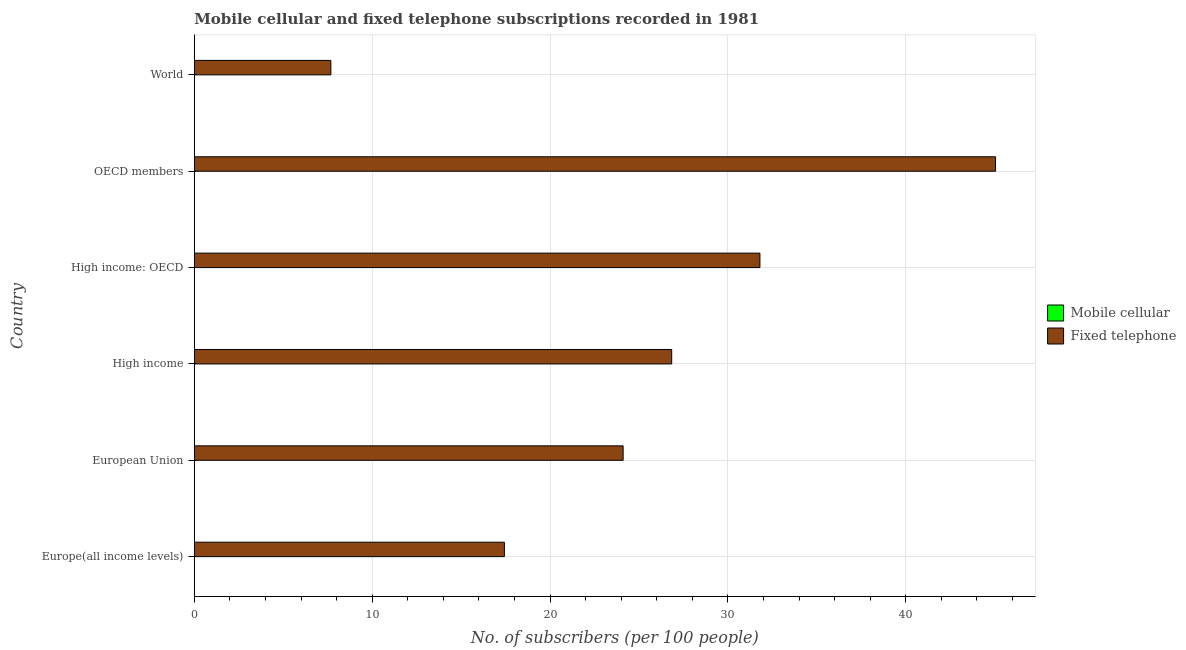How many groups of bars are there?
Your answer should be compact. 6. Are the number of bars per tick equal to the number of legend labels?
Make the answer very short. Yes. How many bars are there on the 4th tick from the bottom?
Ensure brevity in your answer.  2. What is the label of the 1st group of bars from the top?
Provide a short and direct response. World. In how many cases, is the number of bars for a given country not equal to the number of legend labels?
Ensure brevity in your answer.  0. What is the number of fixed telephone subscribers in High income?
Keep it short and to the point. 26.84. Across all countries, what is the maximum number of mobile cellular subscribers?
Ensure brevity in your answer.  0.01. Across all countries, what is the minimum number of mobile cellular subscribers?
Give a very brief answer. 0. In which country was the number of fixed telephone subscribers maximum?
Make the answer very short. OECD members. In which country was the number of mobile cellular subscribers minimum?
Offer a very short reply. World. What is the total number of fixed telephone subscribers in the graph?
Offer a terse response. 152.9. What is the difference between the number of fixed telephone subscribers in Europe(all income levels) and that in OECD members?
Your response must be concise. -27.61. What is the difference between the number of fixed telephone subscribers in World and the number of mobile cellular subscribers in High income: OECD?
Keep it short and to the point. 7.67. What is the average number of mobile cellular subscribers per country?
Make the answer very short. 0.01. What is the difference between the number of mobile cellular subscribers and number of fixed telephone subscribers in High income: OECD?
Your answer should be very brief. -31.79. In how many countries, is the number of fixed telephone subscribers greater than 42 ?
Offer a terse response. 1. What is the ratio of the number of mobile cellular subscribers in European Union to that in High income: OECD?
Keep it short and to the point. 1.06. Is the number of fixed telephone subscribers in Europe(all income levels) less than that in European Union?
Your answer should be very brief. Yes. What is the difference between the highest and the lowest number of fixed telephone subscribers?
Make the answer very short. 37.36. In how many countries, is the number of mobile cellular subscribers greater than the average number of mobile cellular subscribers taken over all countries?
Your answer should be very brief. 3. What does the 1st bar from the top in High income: OECD represents?
Ensure brevity in your answer.  Fixed telephone. What does the 2nd bar from the bottom in Europe(all income levels) represents?
Your answer should be compact. Fixed telephone. How many bars are there?
Your answer should be very brief. 12. Are all the bars in the graph horizontal?
Your response must be concise. Yes. How are the legend labels stacked?
Your answer should be compact. Vertical. What is the title of the graph?
Your response must be concise. Mobile cellular and fixed telephone subscriptions recorded in 1981. What is the label or title of the X-axis?
Make the answer very short. No. of subscribers (per 100 people). What is the No. of subscribers (per 100 people) of Mobile cellular in Europe(all income levels)?
Your answer should be very brief. 0.01. What is the No. of subscribers (per 100 people) in Fixed telephone in Europe(all income levels)?
Provide a succinct answer. 17.43. What is the No. of subscribers (per 100 people) of Mobile cellular in European Union?
Your answer should be compact. 0.01. What is the No. of subscribers (per 100 people) in Fixed telephone in European Union?
Ensure brevity in your answer.  24.11. What is the No. of subscribers (per 100 people) in Mobile cellular in High income?
Your answer should be very brief. 0.01. What is the No. of subscribers (per 100 people) of Fixed telephone in High income?
Make the answer very short. 26.84. What is the No. of subscribers (per 100 people) of Mobile cellular in High income: OECD?
Offer a very short reply. 0.01. What is the No. of subscribers (per 100 people) in Fixed telephone in High income: OECD?
Give a very brief answer. 31.8. What is the No. of subscribers (per 100 people) in Mobile cellular in OECD members?
Offer a very short reply. 0.01. What is the No. of subscribers (per 100 people) in Fixed telephone in OECD members?
Your answer should be compact. 45.04. What is the No. of subscribers (per 100 people) of Mobile cellular in World?
Provide a short and direct response. 0. What is the No. of subscribers (per 100 people) of Fixed telephone in World?
Ensure brevity in your answer.  7.68. Across all countries, what is the maximum No. of subscribers (per 100 people) in Mobile cellular?
Your answer should be very brief. 0.01. Across all countries, what is the maximum No. of subscribers (per 100 people) of Fixed telephone?
Offer a very short reply. 45.04. Across all countries, what is the minimum No. of subscribers (per 100 people) of Mobile cellular?
Offer a very short reply. 0. Across all countries, what is the minimum No. of subscribers (per 100 people) in Fixed telephone?
Ensure brevity in your answer.  7.68. What is the total No. of subscribers (per 100 people) in Mobile cellular in the graph?
Keep it short and to the point. 0.04. What is the total No. of subscribers (per 100 people) of Fixed telephone in the graph?
Offer a very short reply. 152.9. What is the difference between the No. of subscribers (per 100 people) of Mobile cellular in Europe(all income levels) and that in European Union?
Make the answer very short. -0. What is the difference between the No. of subscribers (per 100 people) in Fixed telephone in Europe(all income levels) and that in European Union?
Offer a very short reply. -6.67. What is the difference between the No. of subscribers (per 100 people) in Mobile cellular in Europe(all income levels) and that in High income?
Provide a short and direct response. -0. What is the difference between the No. of subscribers (per 100 people) in Fixed telephone in Europe(all income levels) and that in High income?
Offer a terse response. -9.41. What is the difference between the No. of subscribers (per 100 people) in Mobile cellular in Europe(all income levels) and that in High income: OECD?
Offer a terse response. -0. What is the difference between the No. of subscribers (per 100 people) in Fixed telephone in Europe(all income levels) and that in High income: OECD?
Keep it short and to the point. -14.36. What is the difference between the No. of subscribers (per 100 people) in Mobile cellular in Europe(all income levels) and that in OECD members?
Your answer should be very brief. -0. What is the difference between the No. of subscribers (per 100 people) of Fixed telephone in Europe(all income levels) and that in OECD members?
Ensure brevity in your answer.  -27.61. What is the difference between the No. of subscribers (per 100 people) of Mobile cellular in Europe(all income levels) and that in World?
Your response must be concise. 0. What is the difference between the No. of subscribers (per 100 people) in Fixed telephone in Europe(all income levels) and that in World?
Ensure brevity in your answer.  9.76. What is the difference between the No. of subscribers (per 100 people) in Mobile cellular in European Union and that in High income?
Offer a very short reply. 0. What is the difference between the No. of subscribers (per 100 people) in Fixed telephone in European Union and that in High income?
Your answer should be compact. -2.73. What is the difference between the No. of subscribers (per 100 people) of Mobile cellular in European Union and that in High income: OECD?
Offer a terse response. 0. What is the difference between the No. of subscribers (per 100 people) of Fixed telephone in European Union and that in High income: OECD?
Your answer should be compact. -7.69. What is the difference between the No. of subscribers (per 100 people) in Mobile cellular in European Union and that in OECD members?
Keep it short and to the point. 0. What is the difference between the No. of subscribers (per 100 people) of Fixed telephone in European Union and that in OECD members?
Make the answer very short. -20.93. What is the difference between the No. of subscribers (per 100 people) of Mobile cellular in European Union and that in World?
Make the answer very short. 0.01. What is the difference between the No. of subscribers (per 100 people) in Fixed telephone in European Union and that in World?
Ensure brevity in your answer.  16.43. What is the difference between the No. of subscribers (per 100 people) in Mobile cellular in High income and that in High income: OECD?
Keep it short and to the point. -0. What is the difference between the No. of subscribers (per 100 people) of Fixed telephone in High income and that in High income: OECD?
Provide a short and direct response. -4.96. What is the difference between the No. of subscribers (per 100 people) in Mobile cellular in High income and that in OECD members?
Give a very brief answer. -0. What is the difference between the No. of subscribers (per 100 people) of Fixed telephone in High income and that in OECD members?
Your answer should be very brief. -18.2. What is the difference between the No. of subscribers (per 100 people) in Mobile cellular in High income and that in World?
Your answer should be compact. 0.01. What is the difference between the No. of subscribers (per 100 people) in Fixed telephone in High income and that in World?
Offer a very short reply. 19.16. What is the difference between the No. of subscribers (per 100 people) of Mobile cellular in High income: OECD and that in OECD members?
Offer a very short reply. 0. What is the difference between the No. of subscribers (per 100 people) of Fixed telephone in High income: OECD and that in OECD members?
Keep it short and to the point. -13.24. What is the difference between the No. of subscribers (per 100 people) in Mobile cellular in High income: OECD and that in World?
Your answer should be very brief. 0.01. What is the difference between the No. of subscribers (per 100 people) of Fixed telephone in High income: OECD and that in World?
Your response must be concise. 24.12. What is the difference between the No. of subscribers (per 100 people) of Mobile cellular in OECD members and that in World?
Your response must be concise. 0.01. What is the difference between the No. of subscribers (per 100 people) of Fixed telephone in OECD members and that in World?
Provide a short and direct response. 37.36. What is the difference between the No. of subscribers (per 100 people) of Mobile cellular in Europe(all income levels) and the No. of subscribers (per 100 people) of Fixed telephone in European Union?
Offer a very short reply. -24.1. What is the difference between the No. of subscribers (per 100 people) in Mobile cellular in Europe(all income levels) and the No. of subscribers (per 100 people) in Fixed telephone in High income?
Provide a short and direct response. -26.83. What is the difference between the No. of subscribers (per 100 people) of Mobile cellular in Europe(all income levels) and the No. of subscribers (per 100 people) of Fixed telephone in High income: OECD?
Make the answer very short. -31.79. What is the difference between the No. of subscribers (per 100 people) in Mobile cellular in Europe(all income levels) and the No. of subscribers (per 100 people) in Fixed telephone in OECD members?
Give a very brief answer. -45.04. What is the difference between the No. of subscribers (per 100 people) in Mobile cellular in Europe(all income levels) and the No. of subscribers (per 100 people) in Fixed telephone in World?
Provide a succinct answer. -7.67. What is the difference between the No. of subscribers (per 100 people) in Mobile cellular in European Union and the No. of subscribers (per 100 people) in Fixed telephone in High income?
Offer a terse response. -26.83. What is the difference between the No. of subscribers (per 100 people) of Mobile cellular in European Union and the No. of subscribers (per 100 people) of Fixed telephone in High income: OECD?
Offer a terse response. -31.79. What is the difference between the No. of subscribers (per 100 people) in Mobile cellular in European Union and the No. of subscribers (per 100 people) in Fixed telephone in OECD members?
Offer a very short reply. -45.03. What is the difference between the No. of subscribers (per 100 people) of Mobile cellular in European Union and the No. of subscribers (per 100 people) of Fixed telephone in World?
Provide a succinct answer. -7.67. What is the difference between the No. of subscribers (per 100 people) in Mobile cellular in High income and the No. of subscribers (per 100 people) in Fixed telephone in High income: OECD?
Your answer should be compact. -31.79. What is the difference between the No. of subscribers (per 100 people) in Mobile cellular in High income and the No. of subscribers (per 100 people) in Fixed telephone in OECD members?
Keep it short and to the point. -45.04. What is the difference between the No. of subscribers (per 100 people) of Mobile cellular in High income and the No. of subscribers (per 100 people) of Fixed telephone in World?
Ensure brevity in your answer.  -7.67. What is the difference between the No. of subscribers (per 100 people) in Mobile cellular in High income: OECD and the No. of subscribers (per 100 people) in Fixed telephone in OECD members?
Your answer should be very brief. -45.03. What is the difference between the No. of subscribers (per 100 people) of Mobile cellular in High income: OECD and the No. of subscribers (per 100 people) of Fixed telephone in World?
Make the answer very short. -7.67. What is the difference between the No. of subscribers (per 100 people) in Mobile cellular in OECD members and the No. of subscribers (per 100 people) in Fixed telephone in World?
Make the answer very short. -7.67. What is the average No. of subscribers (per 100 people) in Mobile cellular per country?
Make the answer very short. 0.01. What is the average No. of subscribers (per 100 people) in Fixed telephone per country?
Provide a short and direct response. 25.48. What is the difference between the No. of subscribers (per 100 people) in Mobile cellular and No. of subscribers (per 100 people) in Fixed telephone in Europe(all income levels)?
Provide a short and direct response. -17.43. What is the difference between the No. of subscribers (per 100 people) of Mobile cellular and No. of subscribers (per 100 people) of Fixed telephone in European Union?
Ensure brevity in your answer.  -24.1. What is the difference between the No. of subscribers (per 100 people) of Mobile cellular and No. of subscribers (per 100 people) of Fixed telephone in High income?
Give a very brief answer. -26.83. What is the difference between the No. of subscribers (per 100 people) of Mobile cellular and No. of subscribers (per 100 people) of Fixed telephone in High income: OECD?
Provide a short and direct response. -31.79. What is the difference between the No. of subscribers (per 100 people) in Mobile cellular and No. of subscribers (per 100 people) in Fixed telephone in OECD members?
Give a very brief answer. -45.03. What is the difference between the No. of subscribers (per 100 people) in Mobile cellular and No. of subscribers (per 100 people) in Fixed telephone in World?
Your answer should be very brief. -7.68. What is the ratio of the No. of subscribers (per 100 people) in Mobile cellular in Europe(all income levels) to that in European Union?
Keep it short and to the point. 0.61. What is the ratio of the No. of subscribers (per 100 people) in Fixed telephone in Europe(all income levels) to that in European Union?
Offer a terse response. 0.72. What is the ratio of the No. of subscribers (per 100 people) in Mobile cellular in Europe(all income levels) to that in High income?
Provide a succinct answer. 0.88. What is the ratio of the No. of subscribers (per 100 people) in Fixed telephone in Europe(all income levels) to that in High income?
Ensure brevity in your answer.  0.65. What is the ratio of the No. of subscribers (per 100 people) in Mobile cellular in Europe(all income levels) to that in High income: OECD?
Keep it short and to the point. 0.64. What is the ratio of the No. of subscribers (per 100 people) of Fixed telephone in Europe(all income levels) to that in High income: OECD?
Offer a terse response. 0.55. What is the ratio of the No. of subscribers (per 100 people) of Mobile cellular in Europe(all income levels) to that in OECD members?
Offer a very short reply. 0.76. What is the ratio of the No. of subscribers (per 100 people) in Fixed telephone in Europe(all income levels) to that in OECD members?
Provide a short and direct response. 0.39. What is the ratio of the No. of subscribers (per 100 people) in Mobile cellular in Europe(all income levels) to that in World?
Your answer should be very brief. 4.28. What is the ratio of the No. of subscribers (per 100 people) of Fixed telephone in Europe(all income levels) to that in World?
Your answer should be very brief. 2.27. What is the ratio of the No. of subscribers (per 100 people) in Mobile cellular in European Union to that in High income?
Your answer should be compact. 1.44. What is the ratio of the No. of subscribers (per 100 people) in Fixed telephone in European Union to that in High income?
Your response must be concise. 0.9. What is the ratio of the No. of subscribers (per 100 people) of Mobile cellular in European Union to that in High income: OECD?
Make the answer very short. 1.06. What is the ratio of the No. of subscribers (per 100 people) of Fixed telephone in European Union to that in High income: OECD?
Keep it short and to the point. 0.76. What is the ratio of the No. of subscribers (per 100 people) in Mobile cellular in European Union to that in OECD members?
Provide a short and direct response. 1.25. What is the ratio of the No. of subscribers (per 100 people) in Fixed telephone in European Union to that in OECD members?
Keep it short and to the point. 0.54. What is the ratio of the No. of subscribers (per 100 people) of Mobile cellular in European Union to that in World?
Give a very brief answer. 7.02. What is the ratio of the No. of subscribers (per 100 people) in Fixed telephone in European Union to that in World?
Make the answer very short. 3.14. What is the ratio of the No. of subscribers (per 100 people) in Mobile cellular in High income to that in High income: OECD?
Provide a succinct answer. 0.73. What is the ratio of the No. of subscribers (per 100 people) in Fixed telephone in High income to that in High income: OECD?
Your answer should be compact. 0.84. What is the ratio of the No. of subscribers (per 100 people) of Mobile cellular in High income to that in OECD members?
Offer a very short reply. 0.87. What is the ratio of the No. of subscribers (per 100 people) in Fixed telephone in High income to that in OECD members?
Offer a terse response. 0.6. What is the ratio of the No. of subscribers (per 100 people) of Mobile cellular in High income to that in World?
Provide a short and direct response. 4.87. What is the ratio of the No. of subscribers (per 100 people) of Fixed telephone in High income to that in World?
Make the answer very short. 3.5. What is the ratio of the No. of subscribers (per 100 people) in Mobile cellular in High income: OECD to that in OECD members?
Give a very brief answer. 1.18. What is the ratio of the No. of subscribers (per 100 people) of Fixed telephone in High income: OECD to that in OECD members?
Ensure brevity in your answer.  0.71. What is the ratio of the No. of subscribers (per 100 people) in Mobile cellular in High income: OECD to that in World?
Keep it short and to the point. 6.65. What is the ratio of the No. of subscribers (per 100 people) in Fixed telephone in High income: OECD to that in World?
Your answer should be compact. 4.14. What is the ratio of the No. of subscribers (per 100 people) in Mobile cellular in OECD members to that in World?
Make the answer very short. 5.62. What is the ratio of the No. of subscribers (per 100 people) of Fixed telephone in OECD members to that in World?
Your response must be concise. 5.87. What is the difference between the highest and the second highest No. of subscribers (per 100 people) of Mobile cellular?
Provide a short and direct response. 0. What is the difference between the highest and the second highest No. of subscribers (per 100 people) of Fixed telephone?
Your response must be concise. 13.24. What is the difference between the highest and the lowest No. of subscribers (per 100 people) of Mobile cellular?
Provide a succinct answer. 0.01. What is the difference between the highest and the lowest No. of subscribers (per 100 people) of Fixed telephone?
Make the answer very short. 37.36. 